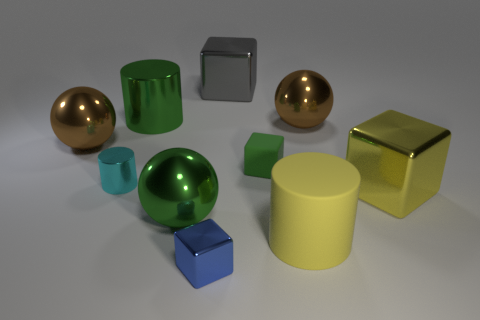Subtract all metal cubes. How many cubes are left? 1 Subtract 1 blocks. How many blocks are left? 3 Subtract all cubes. How many objects are left? 6 Add 8 small yellow cubes. How many small yellow cubes exist? 8 Subtract all yellow cylinders. How many cylinders are left? 2 Subtract 1 yellow cubes. How many objects are left? 9 Subtract all purple cylinders. Subtract all blue cubes. How many cylinders are left? 3 Subtract all yellow blocks. How many red balls are left? 0 Subtract all cyan metallic objects. Subtract all tiny blue objects. How many objects are left? 8 Add 3 tiny objects. How many tiny objects are left? 6 